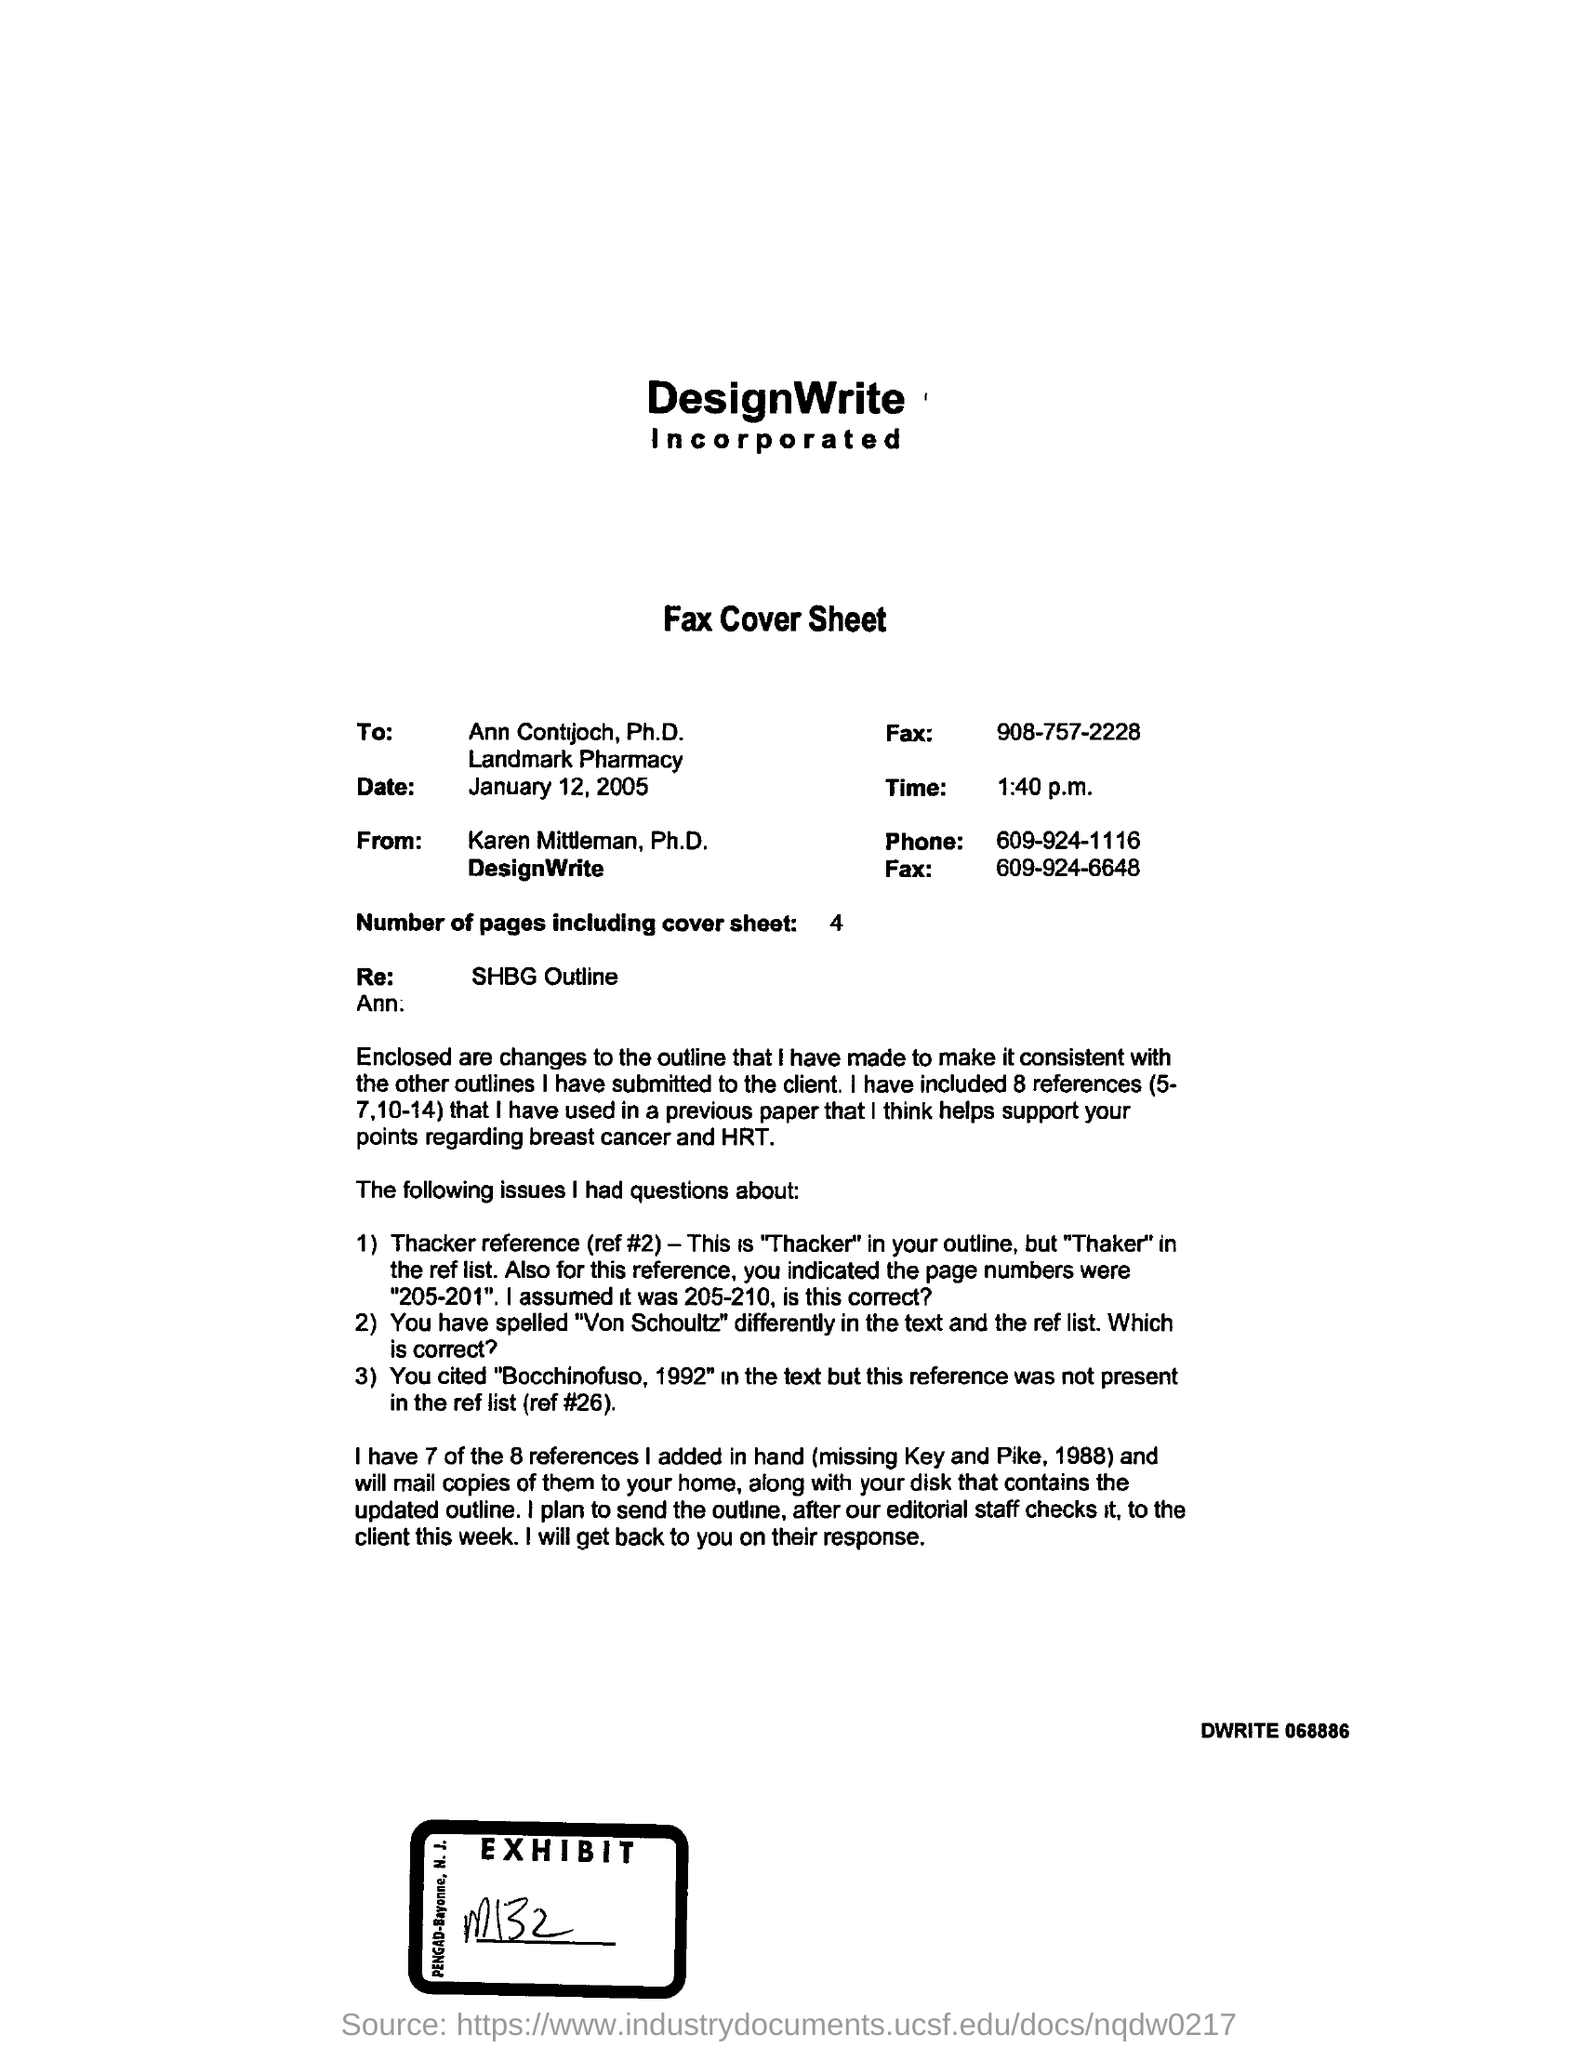Mention a couple of crucial points in this snapshot. The fax cover sheet was sent at 1:40 p.m. 